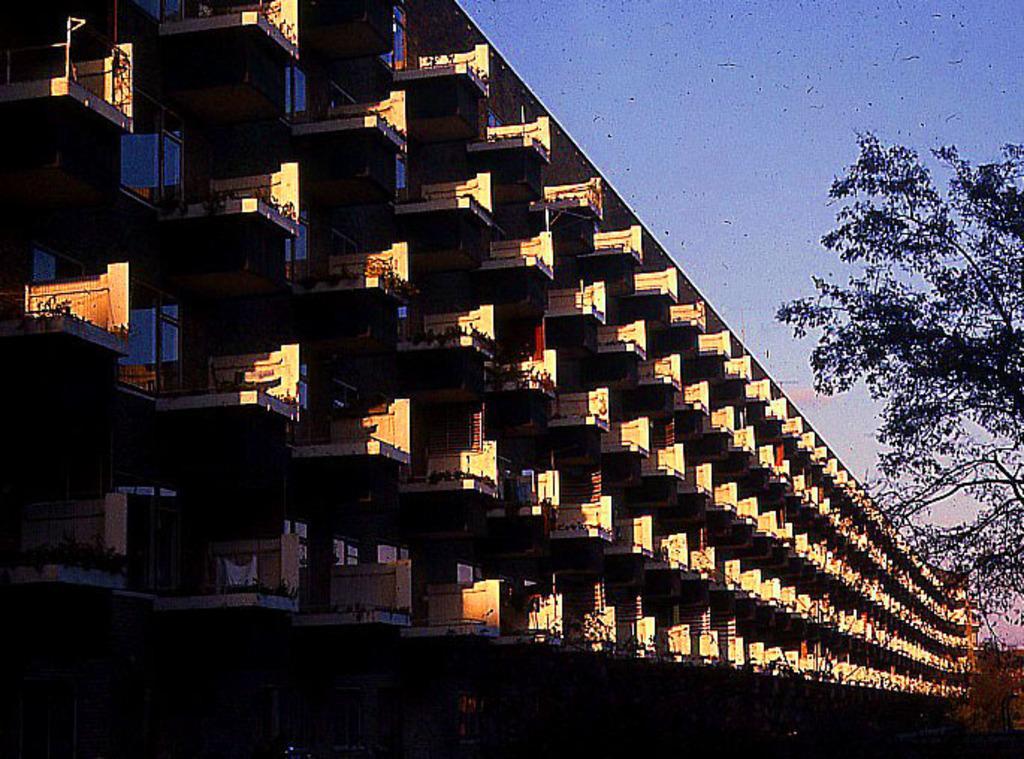Describe this image in one or two sentences. In this picture I can see there is a building and there are trees and the sky is clear. 